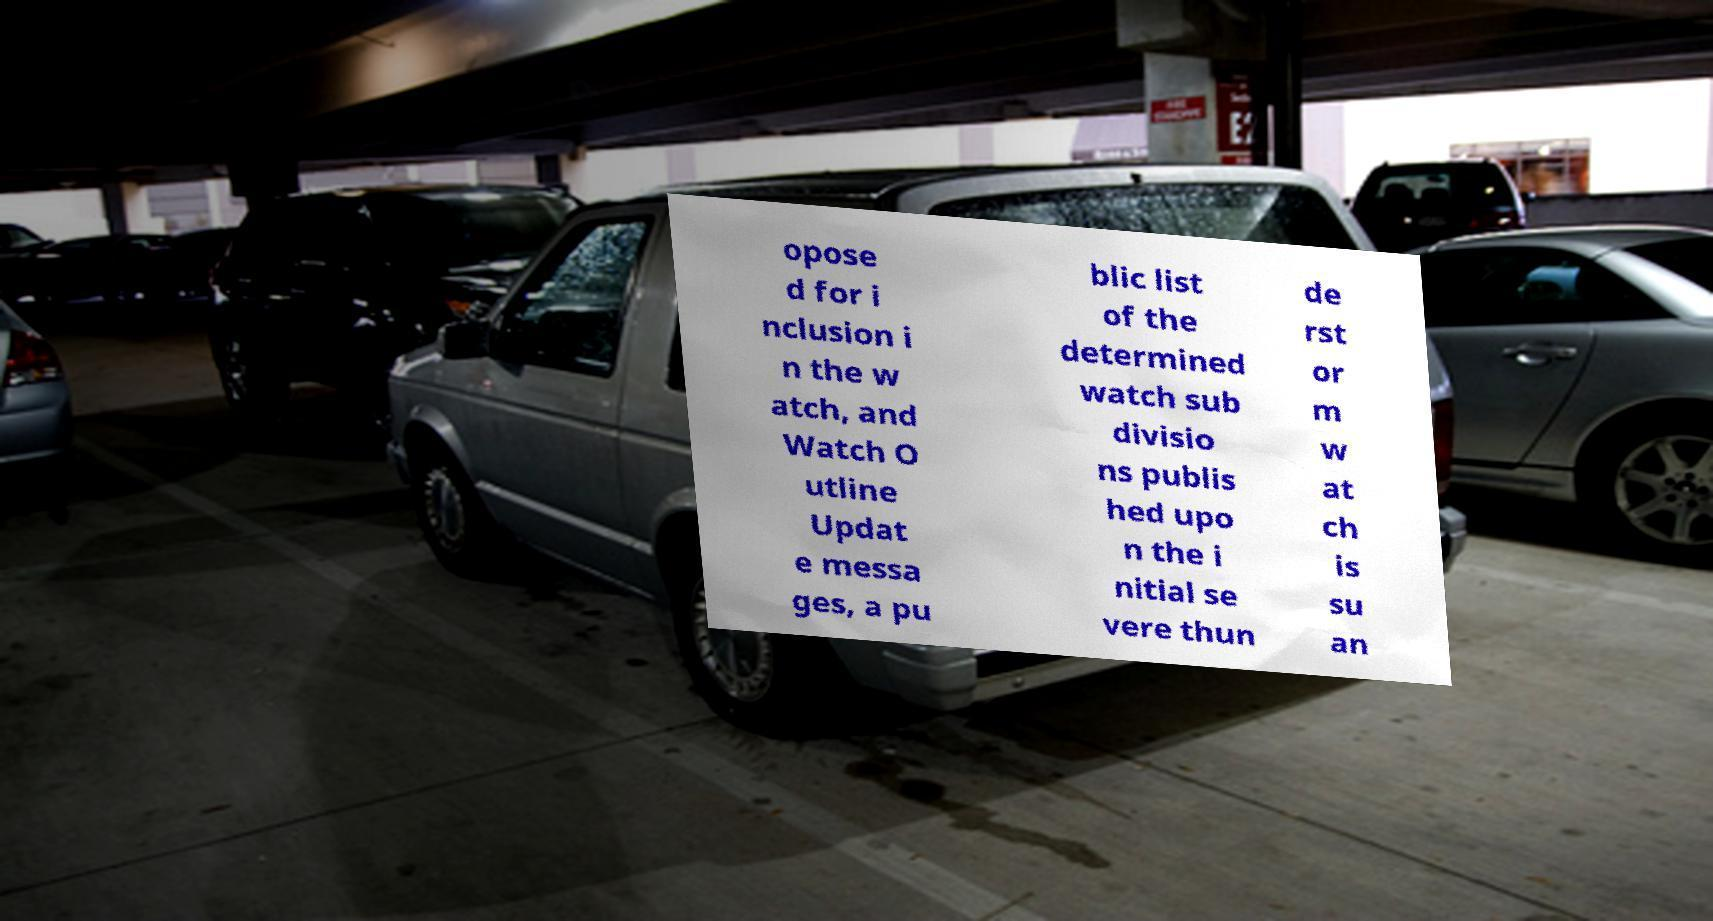Can you accurately transcribe the text from the provided image for me? opose d for i nclusion i n the w atch, and Watch O utline Updat e messa ges, a pu blic list of the determined watch sub divisio ns publis hed upo n the i nitial se vere thun de rst or m w at ch is su an 